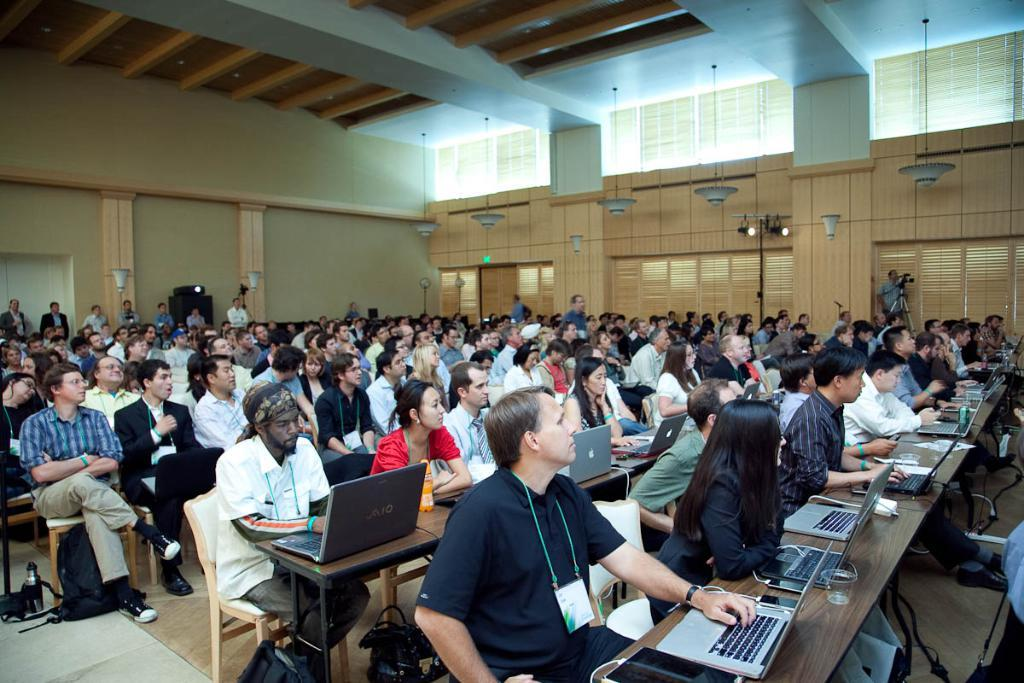What type of structure can be seen in the image? There is a wall in the image. What type of lighting is present in the image? There is a lamp and lights in the image. What type of cooling device is visible in the image? There is a table fan in the image. What are the people in the image doing? There are people sitting on chairs in the image. What type of furniture is present in the image? There are tables in the image. What type of electronic devices are on the tables? There are laptops on the tables. What type of tableware is on the tables? There are glasses on the tables. What type of electrical control device is on the tables? There is a switch board on the tables. What type of feast is being prepared on the tables in the image? There is no feast being prepared in the image; the tables contain laptops, glasses, and a switch board. What type of ball is visible in the image? There is no ball present in the image. 